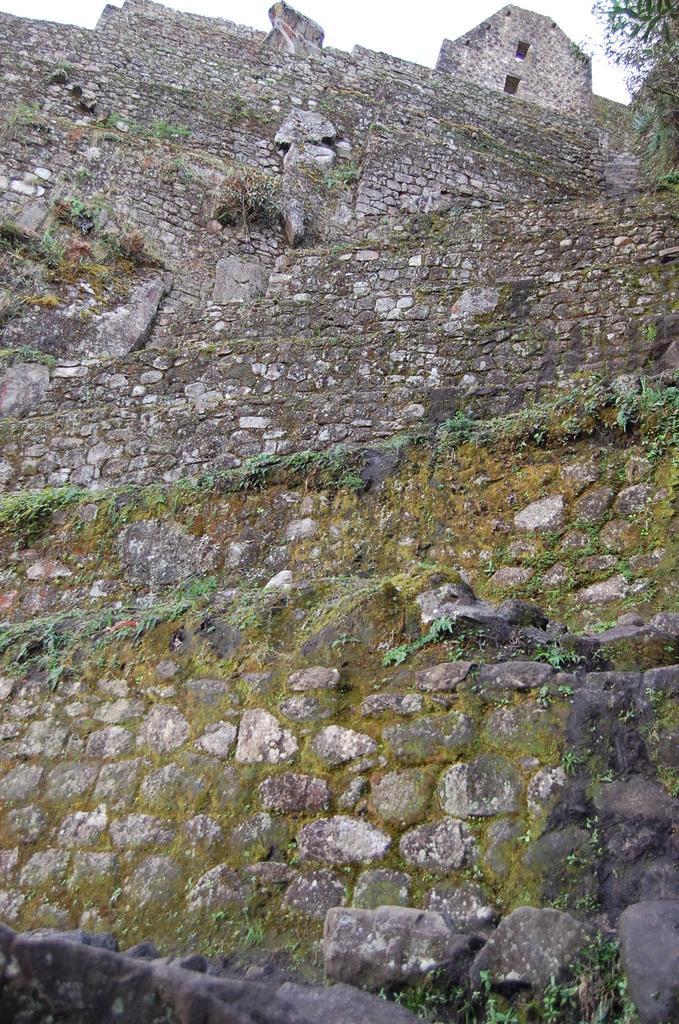How would you summarize this image in a sentence or two? This image consists of a wall made up of rocks. It is very tall. And there are small plants grown in the wall. To the right, there is a tree. To the top, there is a sky. 